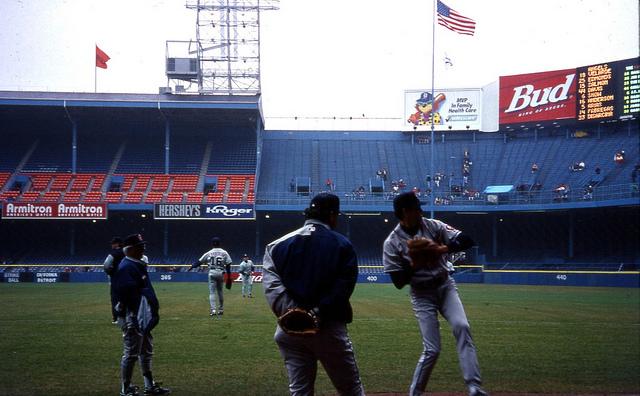How many stars in the Budweiser sign?
Short answer required. 0. Is the place crowded?
Keep it brief. No. In what country are they playing?
Concise answer only. Usa. Bud is short for what?
Give a very brief answer. Budweiser. What candy brand do you see advertised?
Write a very short answer. Hershey's. Whose home stadium is this?
Keep it brief. Cubs. 